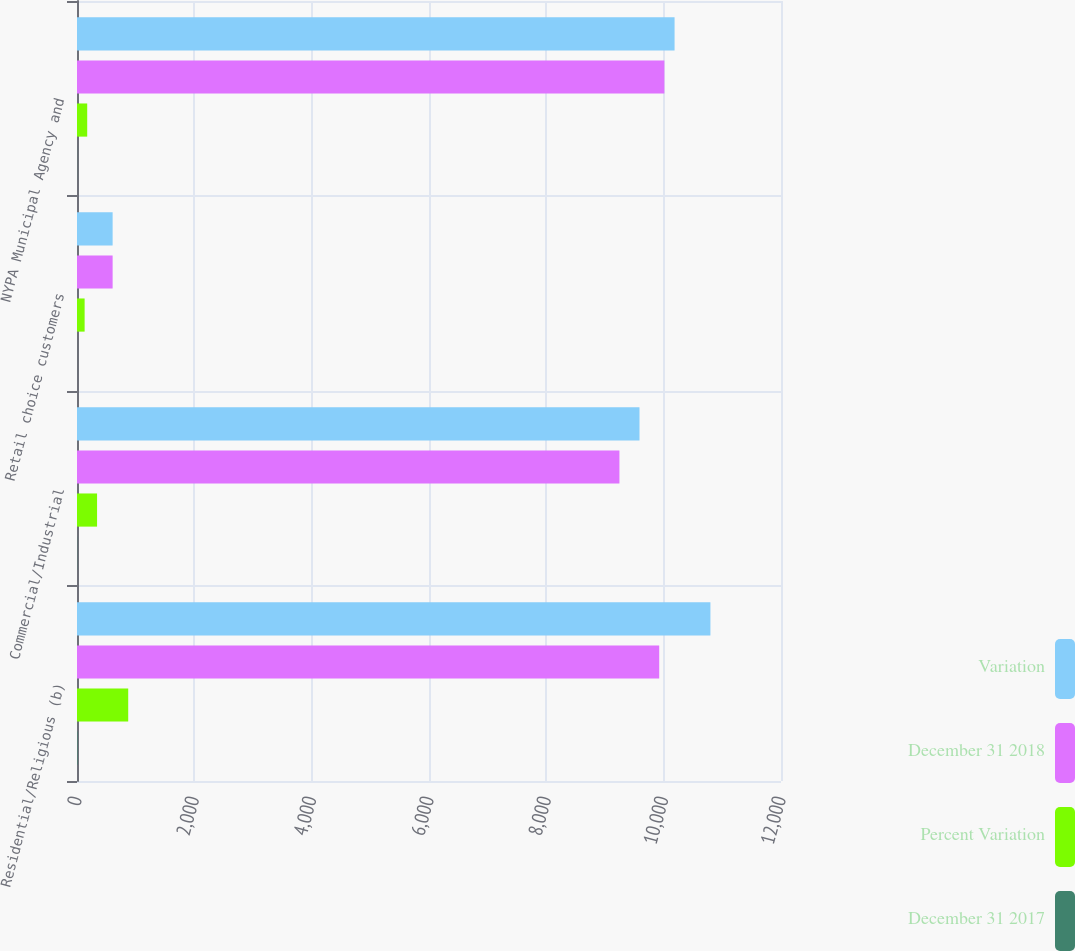Convert chart to OTSL. <chart><loc_0><loc_0><loc_500><loc_500><stacked_bar_chart><ecel><fcel>Residential/Religious (b)<fcel>Commercial/Industrial<fcel>Retail choice customers<fcel>NYPA Municipal Agency and<nl><fcel>Variation<fcel>10797<fcel>9588<fcel>607.5<fcel>10186<nl><fcel>December 31 2018<fcel>9924<fcel>9246<fcel>607.5<fcel>10012<nl><fcel>Percent Variation<fcel>873<fcel>342<fcel>130<fcel>174<nl><fcel>December 31 2017<fcel>8.8<fcel>3.7<fcel>0.5<fcel>1.7<nl></chart> 